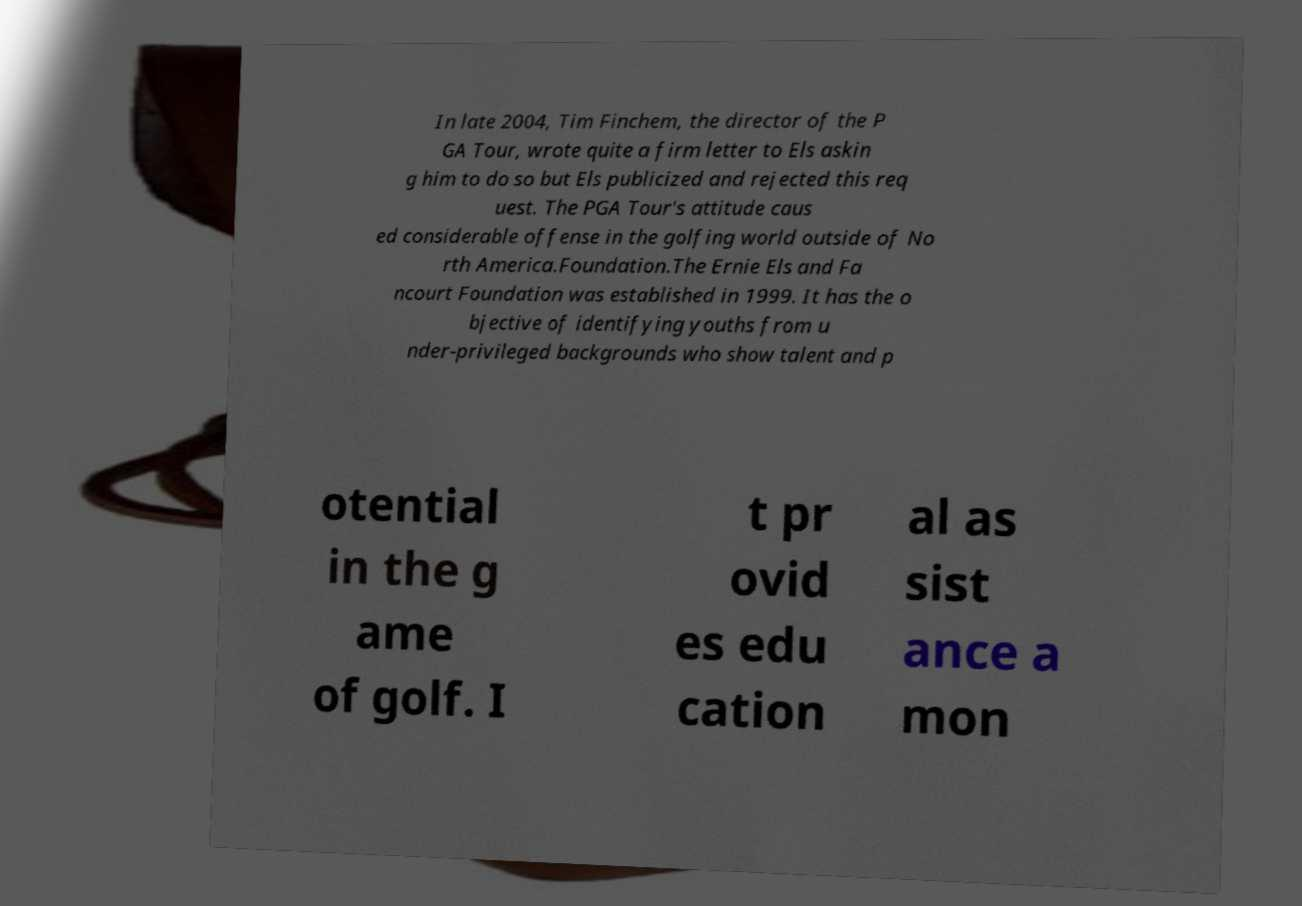Could you extract and type out the text from this image? In late 2004, Tim Finchem, the director of the P GA Tour, wrote quite a firm letter to Els askin g him to do so but Els publicized and rejected this req uest. The PGA Tour's attitude caus ed considerable offense in the golfing world outside of No rth America.Foundation.The Ernie Els and Fa ncourt Foundation was established in 1999. It has the o bjective of identifying youths from u nder-privileged backgrounds who show talent and p otential in the g ame of golf. I t pr ovid es edu cation al as sist ance a mon 